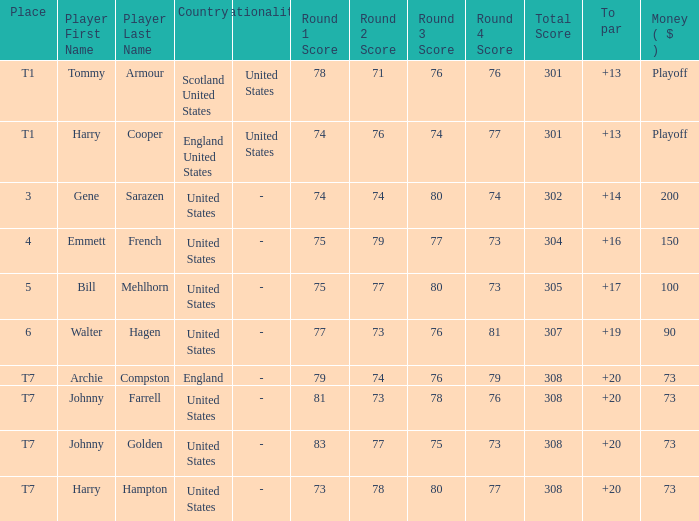When the player is archie compston and the sum is $73, what is his position in the ranking? T7. Would you be able to parse every entry in this table? {'header': ['Place', 'Player First Name', 'Player Last Name', 'Country', 'Nationality', 'Round 1 Score', 'Round 2 Score', 'Round 3 Score', 'Round 4 Score', 'Total Score', 'To par', 'Money ( $ )'], 'rows': [['T1', 'Tommy', 'Armour', 'Scotland United States', 'United States', '78', '71', '76', '76', '301', '+13', 'Playoff'], ['T1', 'Harry', 'Cooper', 'England United States', 'United States', '74', '76', '74', '77', '301', '+13', 'Playoff'], ['3', 'Gene', 'Sarazen', 'United States', '-', '74', '74', '80', '74', '302', '+14', '200'], ['4', 'Emmett', 'French', 'United States', '-', '75', '79', '77', '73', '304', '+16', '150'], ['5', 'Bill', 'Mehlhorn', 'United States', '-', '75', '77', '80', '73', '305', '+17', '100'], ['6', 'Walter', 'Hagen', 'United States', '-', '77', '73', '76', '81', '307', '+19', '90'], ['T7', 'Archie', 'Compston', 'England', '-', '79', '74', '76', '79', '308', '+20', '73'], ['T7', 'Johnny', 'Farrell', 'United States', '-', '81', '73', '78', '76', '308', '+20', '73'], ['T7', 'Johnny', 'Golden', 'United States', '-', '83', '77', '75', '73', '308', '+20', '73'], ['T7', 'Harry', 'Hampton', 'United States', '-', '73', '78', '80', '77', '308', '+20', '73']]} 